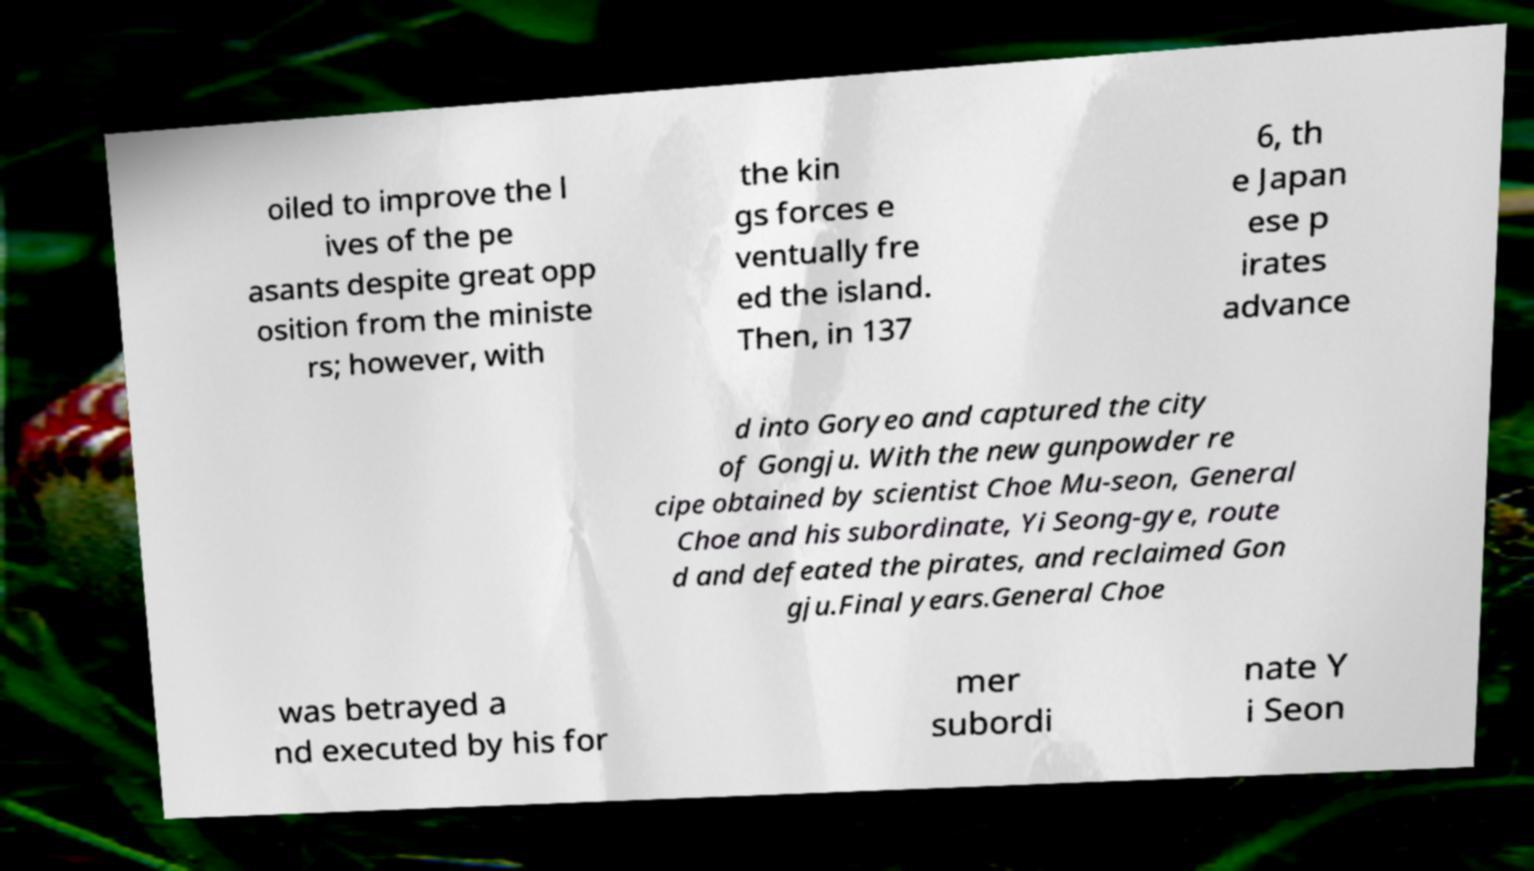Can you accurately transcribe the text from the provided image for me? oiled to improve the l ives of the pe asants despite great opp osition from the ministe rs; however, with the kin gs forces e ventually fre ed the island. Then, in 137 6, th e Japan ese p irates advance d into Goryeo and captured the city of Gongju. With the new gunpowder re cipe obtained by scientist Choe Mu-seon, General Choe and his subordinate, Yi Seong-gye, route d and defeated the pirates, and reclaimed Gon gju.Final years.General Choe was betrayed a nd executed by his for mer subordi nate Y i Seon 